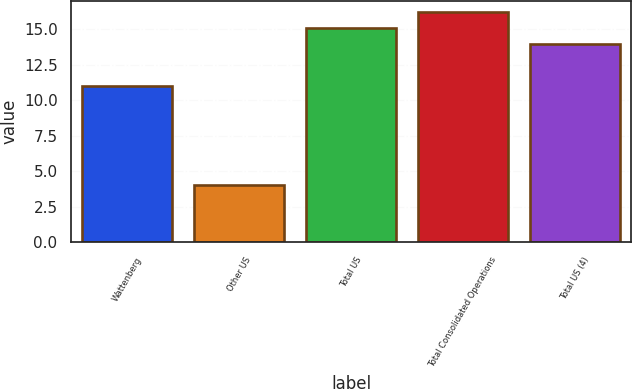Convert chart to OTSL. <chart><loc_0><loc_0><loc_500><loc_500><bar_chart><fcel>Wattenberg<fcel>Other US<fcel>Total US<fcel>Total Consolidated Operations<fcel>Total US (4)<nl><fcel>11<fcel>4<fcel>15.1<fcel>16.2<fcel>14<nl></chart> 